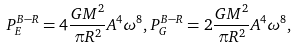Convert formula to latex. <formula><loc_0><loc_0><loc_500><loc_500>P ^ { B - R } _ { E } = 4 \frac { G M ^ { 2 } } { \pi R ^ { 2 } } A ^ { 4 } \omega ^ { 8 } , P ^ { B - R } _ { G } = 2 \frac { G M ^ { 2 } } { \pi R ^ { 2 } } A ^ { 4 } \omega ^ { 8 } ,</formula> 